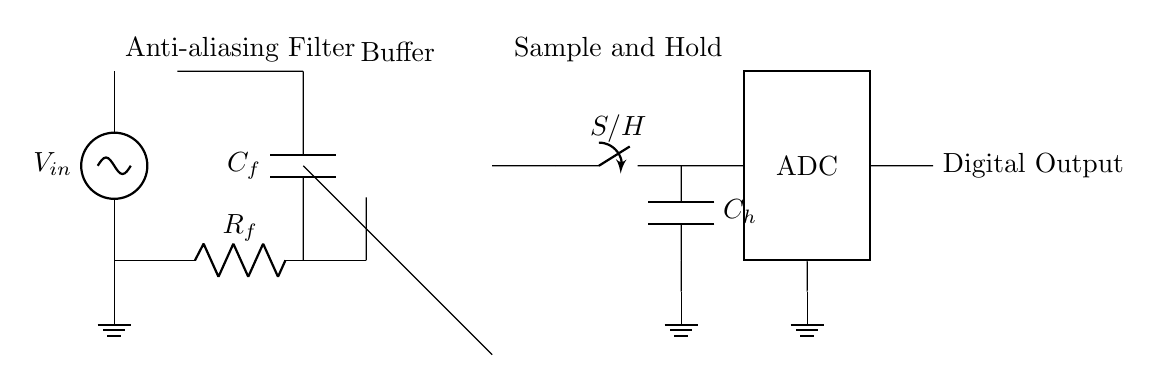What is the input voltage in this circuit? The input voltage is labeled as V_in on the circuit diagram. It is the voltage applied to the input of the anti-aliasing filter.
Answer: V_in What component is used for anti-aliasing in this circuit? The circuit uses a resistor-capacitor (RC) network consisting of R_f and C_f for anti-aliasing. This combination filters out high-frequency signals that could cause aliasing in the conversion process.
Answer: R_f and C_f What does the op amp do in this circuit? The op amp serves as a buffer amplifier, allowing the signal to be transferred without loading the previous stage. This preserves the signal integrity before it is sampled.
Answer: Buffer amplifier What is the function of the switch labeled S/H? The switch S/H is for the sample and hold function, which captures and holds the voltage level of the signal at the moment the switch is activated, allowing the ADC to process a stable signal.
Answer: Sample and hold How many main components are involved in the signal processing of this circuit before the ADC? There are three main components involved: the anti-aliasing filter, the buffer amplifier, and the sample and hold circuit, which all contribute to preparing the signal for conversion.
Answer: Three What is the role of the capacitor labeled C_h? The capacitor C_h in the sample and hold circuit stores the voltage from the input signal temporarily, holding it steady until the ADC takes its measurement, ensuring the accuracy of the digital representation.
Answer: Store voltage What type of output does this circuit produce? The output produced by the ADC is a digital signal that represents the sampled analog input voltage. This digital representation allows for easier processing and analysis in digital systems.
Answer: Digital Output 